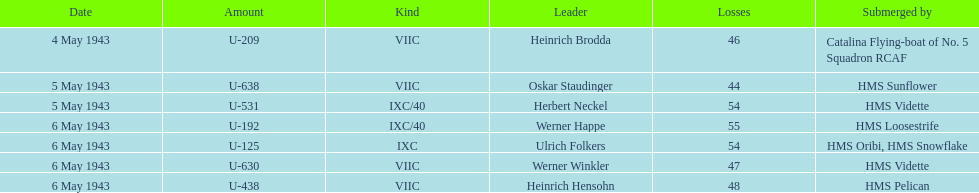Which u-boat was the first to sink U-209. 